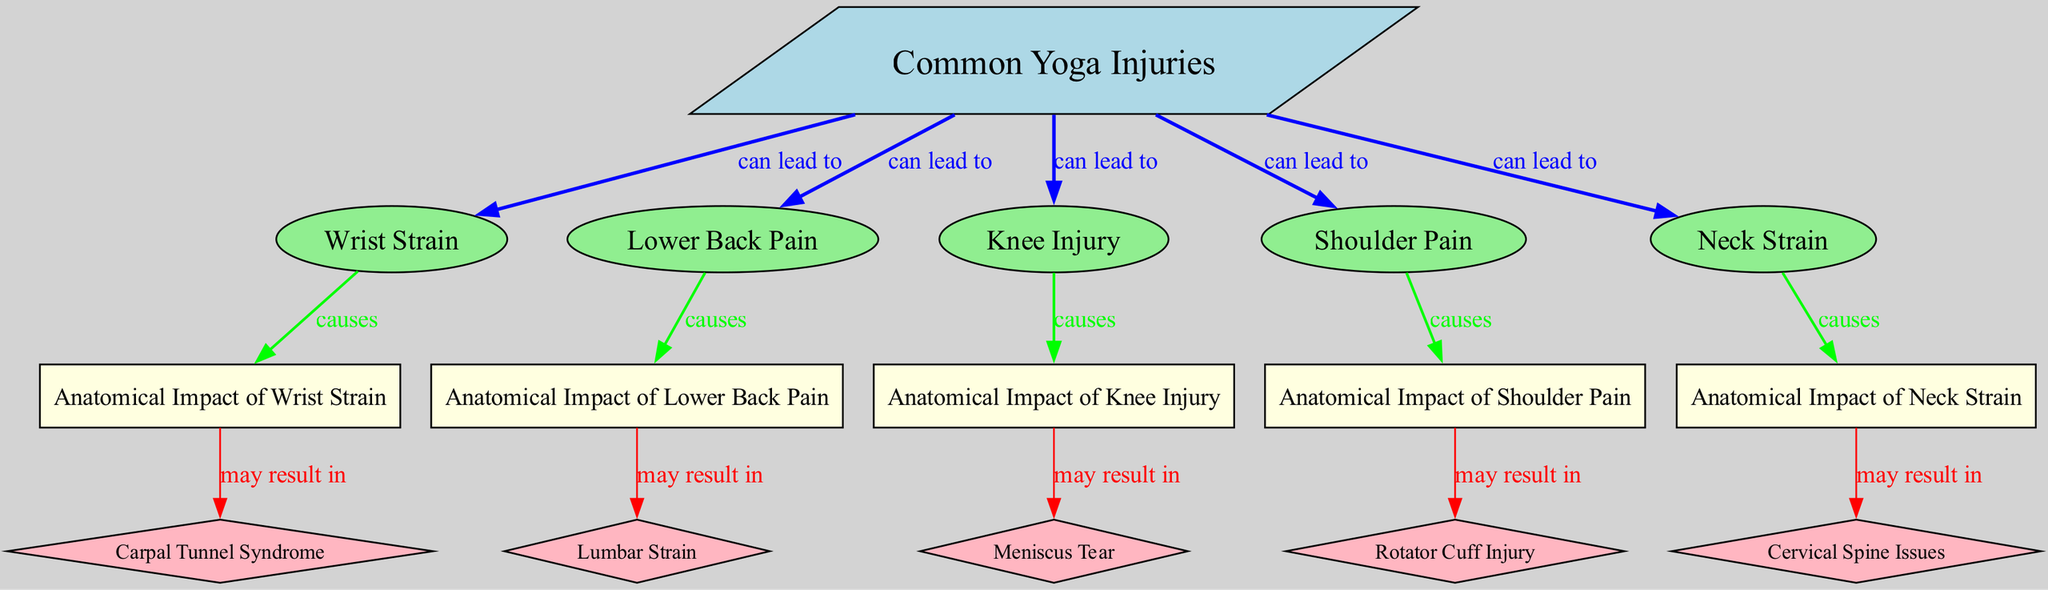What injuries are listed under common yoga injuries? The diagram lists Wrist Strain, Lower Back Pain, Knee Injury, Shoulder Pain, and Neck Strain as common yoga injuries.
Answer: Wrist Strain, Lower Back Pain, Knee Injury, Shoulder Pain, Neck Strain How many common yoga injuries are there? Counting the nodes under "Common Yoga Injuries", we find five different injuries listed.
Answer: 5 What does "Knee Injury" may result in? The diagram indicates that a Knee Injury may result in a Meniscus Tear.
Answer: Meniscus Tear What type of injury is associated with "Wrist Strain"? The diagram states that "Wrist Strain" causes Anatomical Impact of Wrist Strain, specifically leading to potential Carpal Tunnel Syndrome.
Answer: Carpal Tunnel Syndrome Which common injury leads to the most anatomical impacts? Evaluating the connections, "Shoulder Pain" leads to a specific injury (Rotator Cuff Injury), making it significant in terms of causes, but in terms of multiple possible outcomes, it might be argued that "Lower Back Pain" leads to Lumbar Strain.
Answer: Lower Back Pain What is the relationship between "Neck Strain" and "Cervical Spine Issues"? The diagram illustrates that Neck Strain causes Anatomical Impact of Neck Strain, which may result in Cervical Spine Issues. This indicates a direct causal connection between the two.
Answer: causes How many edges are drawn for "Common Yoga Injuries"? The edges indicate interactions with different common injuries, totaling five directed connections from "Common Yoga Injuries" to each specific injury node.
Answer: 5 Which injury is connected to the "Anatomical Impact of Shoulder Pain"? The diagram specifies that "Shoulder Pain" leads to the "Anatomical Impact of Shoulder Pain," which may result in a Rotator Cuff Injury, illustrating a secondary impact.
Answer: Rotator Cuff Injury What might "Lower Back Pain" lead to? According to the diagram, Lower Back Pain causes Anatomical Impact of Lower Back Pain, which may result in a Lumbar Strain.
Answer: Lumbar Strain 